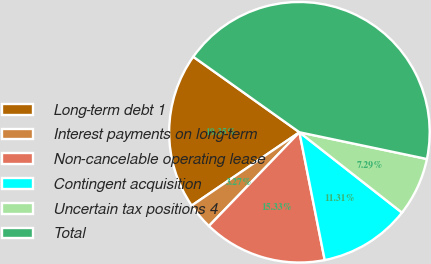Convert chart to OTSL. <chart><loc_0><loc_0><loc_500><loc_500><pie_chart><fcel>Long-term debt 1<fcel>Interest payments on long-term<fcel>Non-cancelable operating lease<fcel>Contingent acquisition<fcel>Uncertain tax positions 4<fcel>Total<nl><fcel>19.35%<fcel>3.27%<fcel>15.33%<fcel>11.31%<fcel>7.29%<fcel>43.45%<nl></chart> 